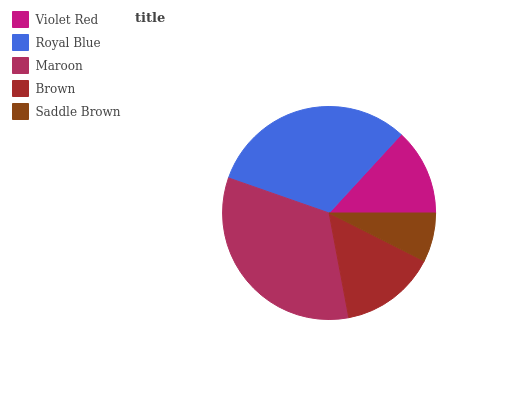Is Saddle Brown the minimum?
Answer yes or no. Yes. Is Maroon the maximum?
Answer yes or no. Yes. Is Royal Blue the minimum?
Answer yes or no. No. Is Royal Blue the maximum?
Answer yes or no. No. Is Royal Blue greater than Violet Red?
Answer yes or no. Yes. Is Violet Red less than Royal Blue?
Answer yes or no. Yes. Is Violet Red greater than Royal Blue?
Answer yes or no. No. Is Royal Blue less than Violet Red?
Answer yes or no. No. Is Brown the high median?
Answer yes or no. Yes. Is Brown the low median?
Answer yes or no. Yes. Is Violet Red the high median?
Answer yes or no. No. Is Saddle Brown the low median?
Answer yes or no. No. 